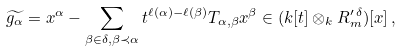Convert formula to latex. <formula><loc_0><loc_0><loc_500><loc_500>\widetilde { g _ { \alpha } } = x ^ { \alpha } - \sum _ { \beta \in \delta , \beta \prec \alpha } t ^ { \ell ( \alpha ) - \ell ( \beta ) } T _ { \alpha , \beta } x ^ { \beta } \in ( k [ t ] \otimes _ { k } R ^ { \prime \, \delta } _ { m } ) [ x ] \, ,</formula> 